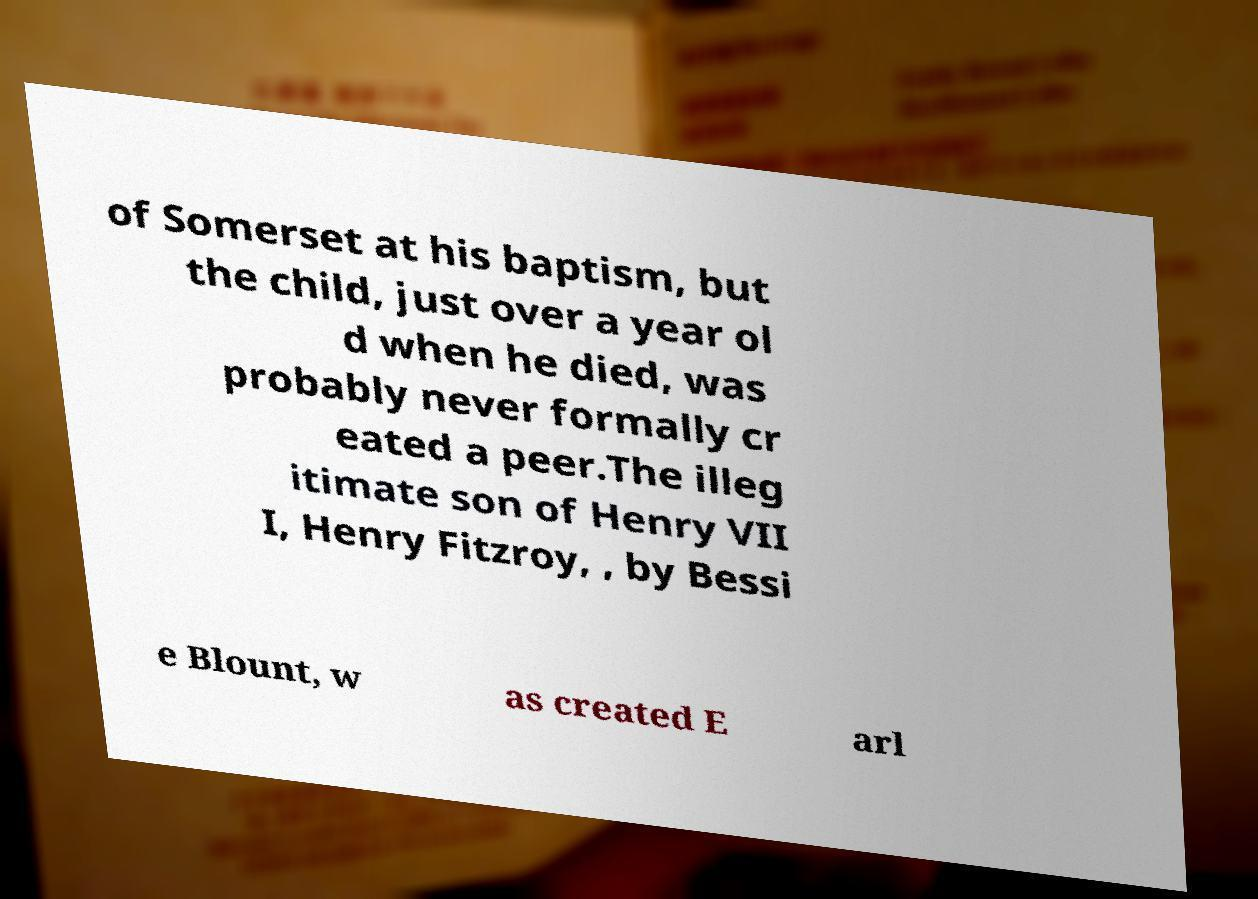For documentation purposes, I need the text within this image transcribed. Could you provide that? of Somerset at his baptism, but the child, just over a year ol d when he died, was probably never formally cr eated a peer.The illeg itimate son of Henry VII I, Henry Fitzroy, , by Bessi e Blount, w as created E arl 